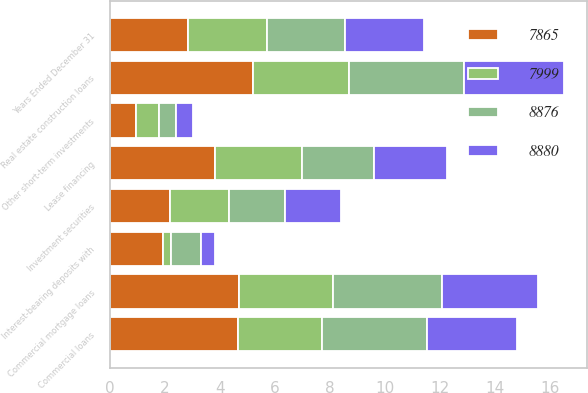<chart> <loc_0><loc_0><loc_500><loc_500><stacked_bar_chart><ecel><fcel>Years Ended December 31<fcel>Interest-bearing deposits with<fcel>Other short-term investments<fcel>Investment securities<fcel>Commercial loans<fcel>Real estate construction loans<fcel>Commercial mortgage loans<fcel>Lease financing<nl><fcel>7865<fcel>2.85<fcel>1.94<fcel>0.96<fcel>2.19<fcel>4.64<fcel>5.21<fcel>4.69<fcel>3.82<nl><fcel>8876<fcel>2.85<fcel>1.09<fcel>0.64<fcel>2.05<fcel>3.82<fcel>4.18<fcel>3.97<fcel>2.63<nl><fcel>8880<fcel>2.85<fcel>0.51<fcel>0.61<fcel>2.02<fcel>3.25<fcel>3.63<fcel>3.49<fcel>2.64<nl><fcel>7999<fcel>2.85<fcel>0.26<fcel>0.81<fcel>2.13<fcel>3.06<fcel>3.48<fcel>3.41<fcel>3.15<nl></chart> 